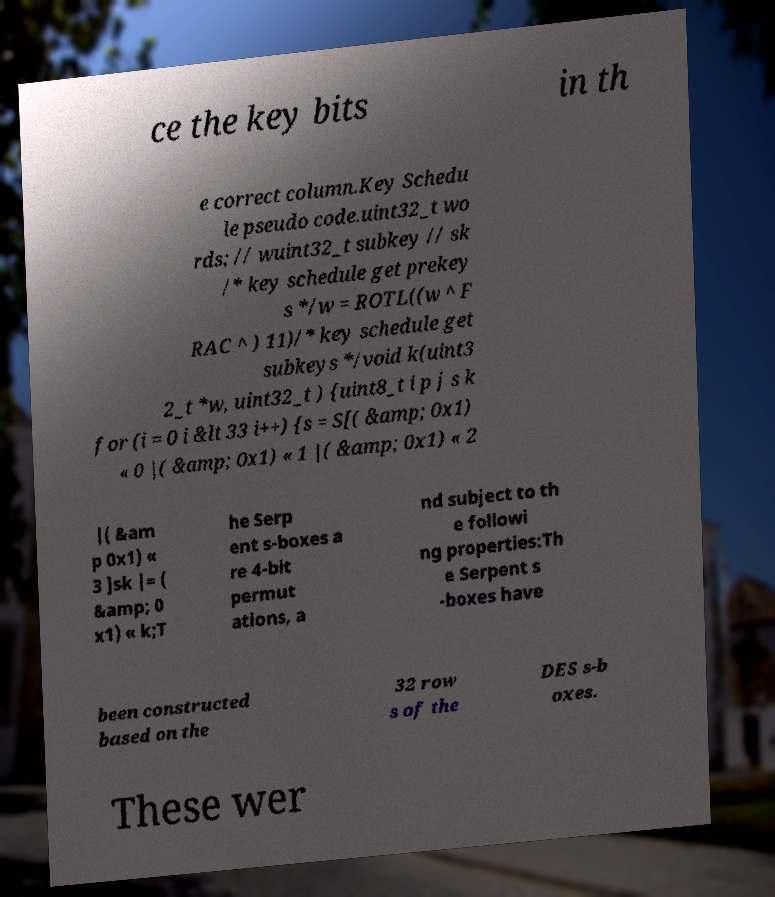Could you extract and type out the text from this image? ce the key bits in th e correct column.Key Schedu le pseudo code.uint32_t wo rds; // wuint32_t subkey // sk /* key schedule get prekey s */w = ROTL((w ^ F RAC ^ ) 11)/* key schedule get subkeys */void k(uint3 2_t *w, uint32_t ) {uint8_t i p j s k for (i = 0 i &lt 33 i++) {s = S[( &amp; 0x1) « 0 |( &amp; 0x1) « 1 |( &amp; 0x1) « 2 |( &am p 0x1) « 3 ]sk |= ( &amp; 0 x1) « k;T he Serp ent s-boxes a re 4-bit permut ations, a nd subject to th e followi ng properties:Th e Serpent s -boxes have been constructed based on the 32 row s of the DES s-b oxes. These wer 